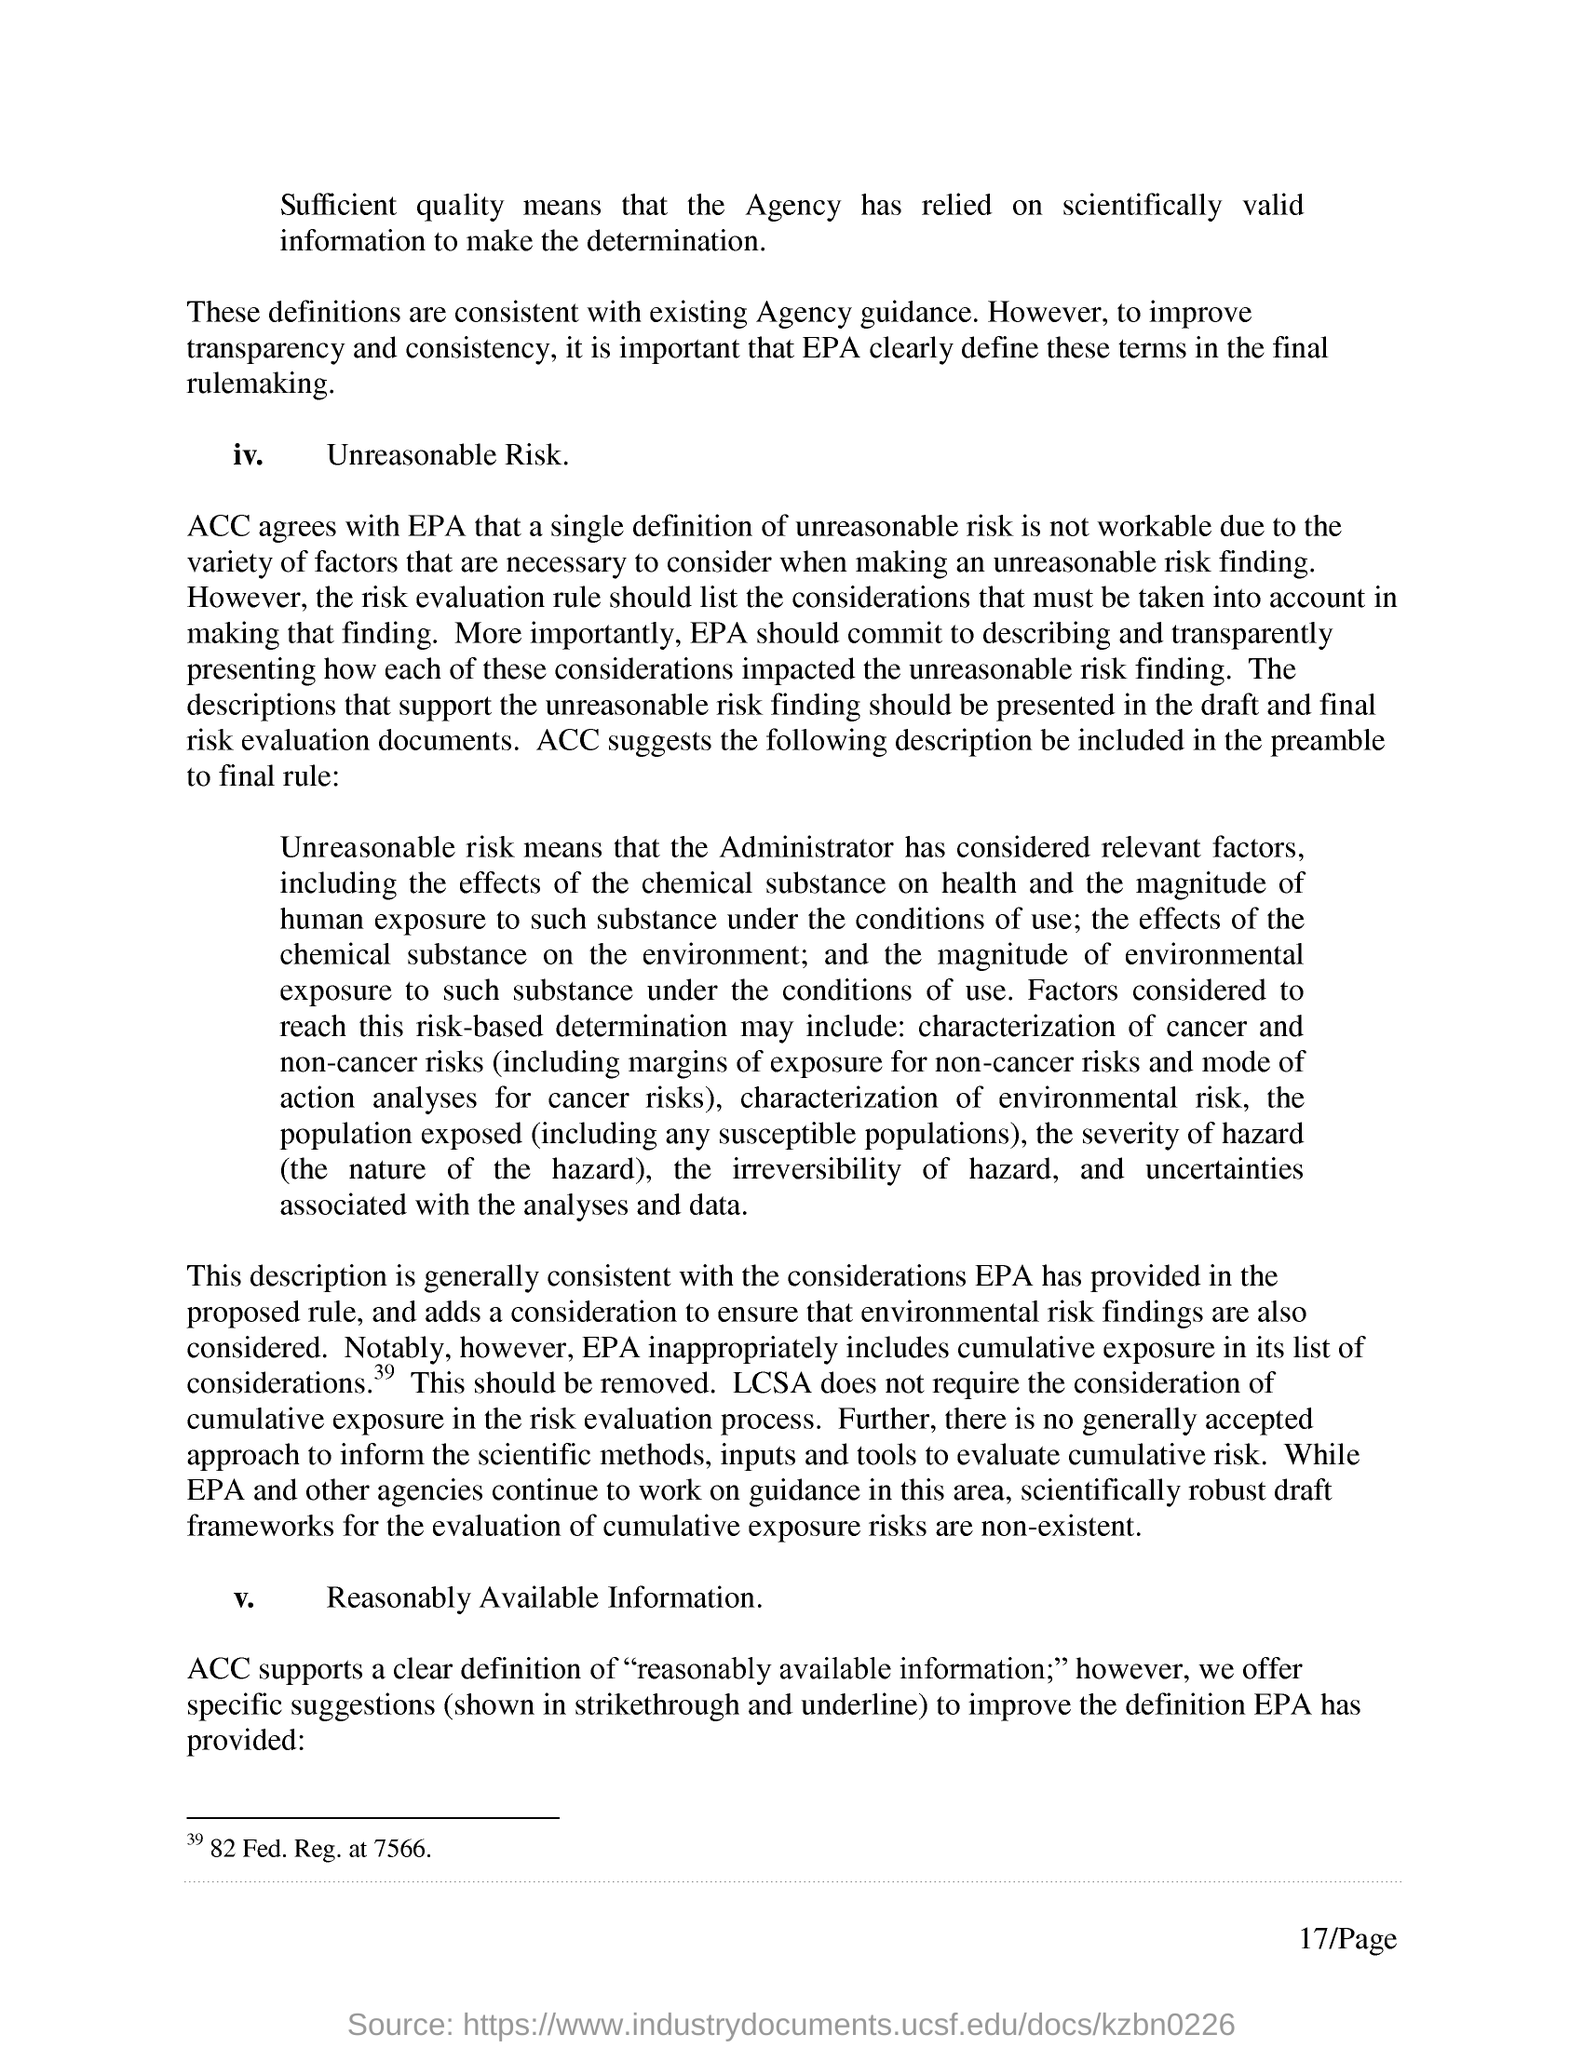Draw attention to some important aspects in this diagram. The page number mentioned in this document is 17/Page. ACC supports a clear definition of 'reasonably available information' as a term used in accounting and financial reporting. 